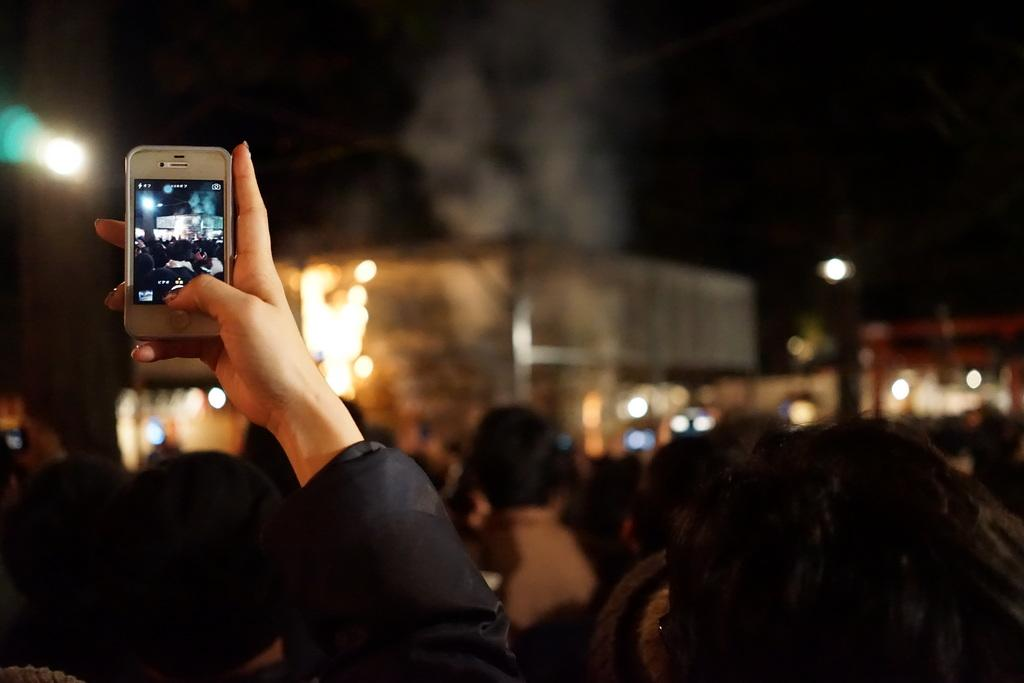What is the setting of the image? The image is taken in a crowd. What is the person in the image doing? The person is holding a camera and capturing an image. What can be seen in the background of the image? There are buildings and lights in the background of the image. How many ladybugs can be seen on the person's foot in the image? There are no ladybugs visible on the person's foot in the image. What is the afterthought of the person holding the camera in the image? The provided facts do not mention any afterthoughts or intentions of the person holding the camera, so we cannot determine their afterthought from the image. 